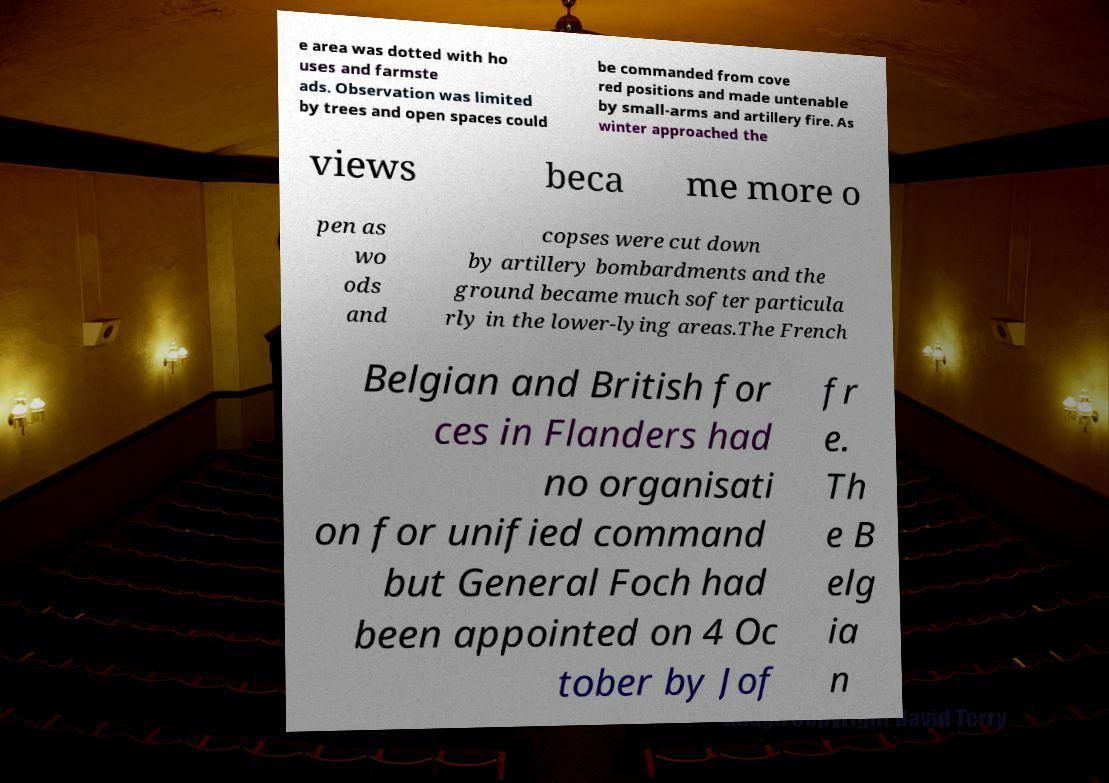There's text embedded in this image that I need extracted. Can you transcribe it verbatim? e area was dotted with ho uses and farmste ads. Observation was limited by trees and open spaces could be commanded from cove red positions and made untenable by small-arms and artillery fire. As winter approached the views beca me more o pen as wo ods and copses were cut down by artillery bombardments and the ground became much softer particula rly in the lower-lying areas.The French Belgian and British for ces in Flanders had no organisati on for unified command but General Foch had been appointed on 4 Oc tober by Jof fr e. Th e B elg ia n 